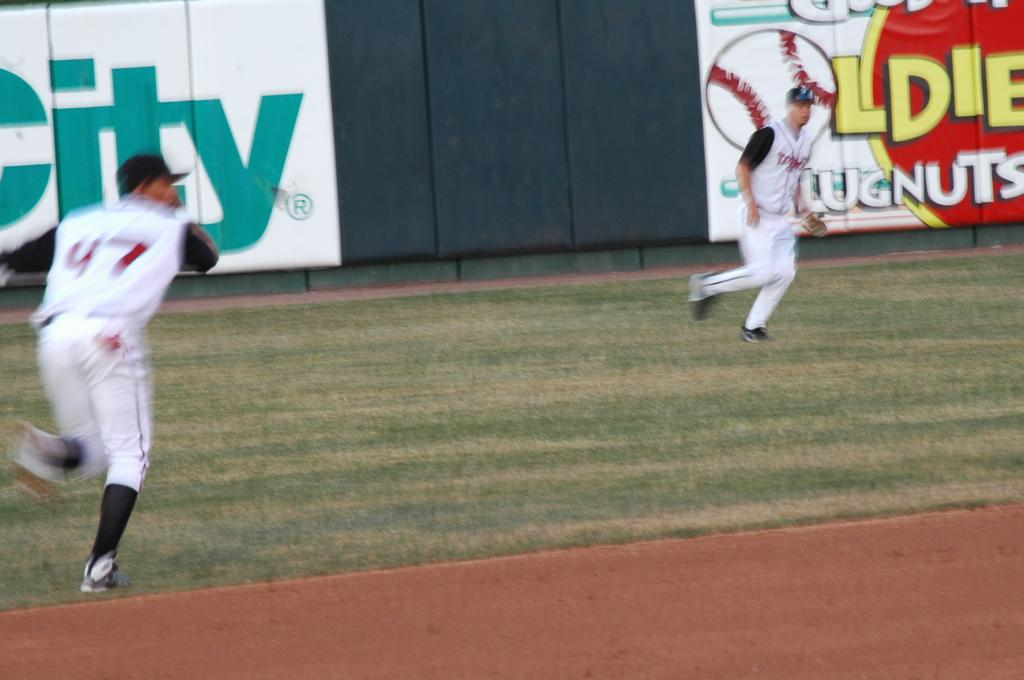<image>
Provide a brief description of the given image. Man running to the base wearing number 47. 